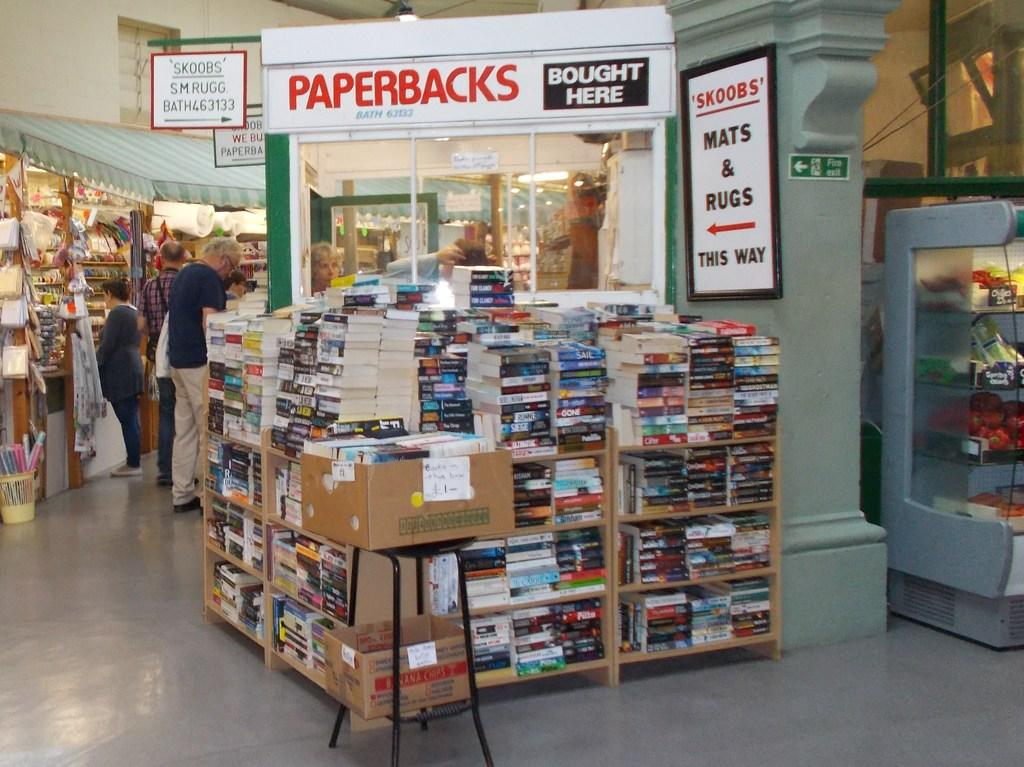<image>
Offer a succinct explanation of the picture presented. A stack of books with a sign saying paperbacks can be bought 